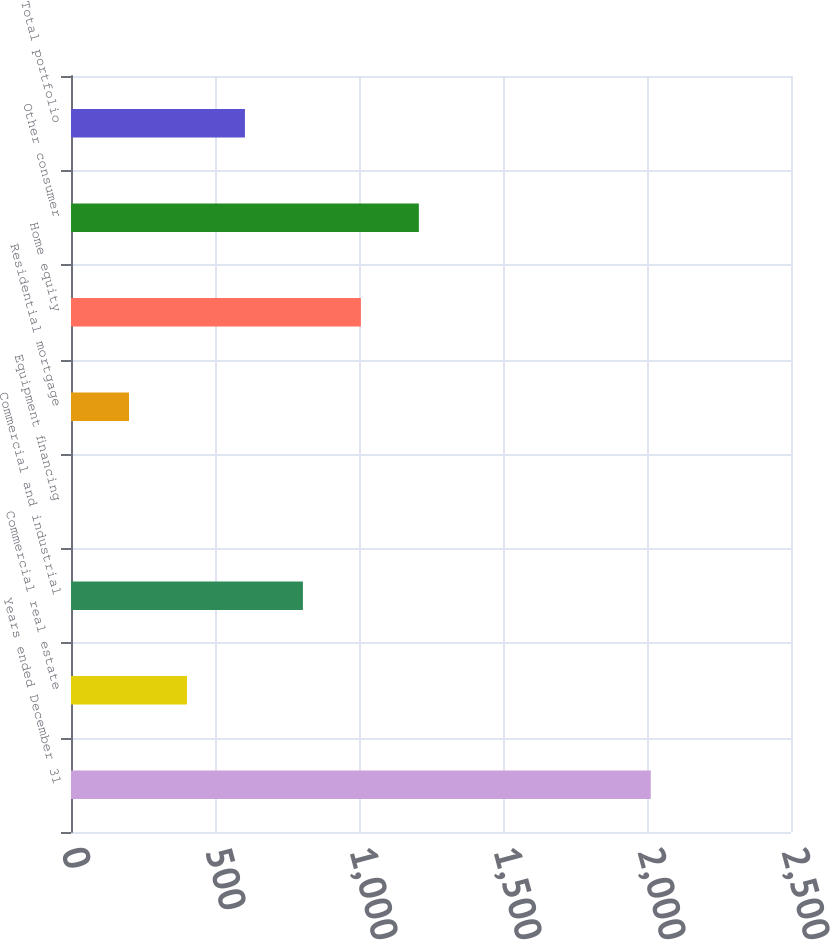Convert chart. <chart><loc_0><loc_0><loc_500><loc_500><bar_chart><fcel>Years ended December 31<fcel>Commercial real estate<fcel>Commercial and industrial<fcel>Equipment financing<fcel>Residential mortgage<fcel>Home equity<fcel>Other consumer<fcel>Total portfolio<nl><fcel>2013<fcel>402.66<fcel>805.24<fcel>0.08<fcel>201.37<fcel>1006.53<fcel>1207.82<fcel>603.95<nl></chart> 